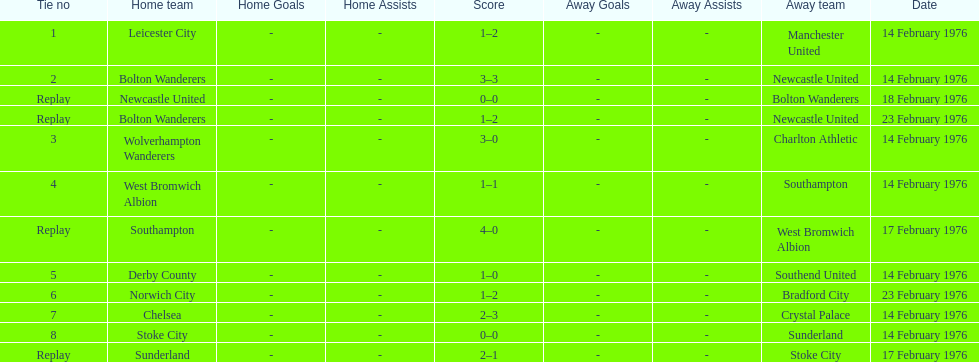What was the goal difference in the game on february 18th? 0. 